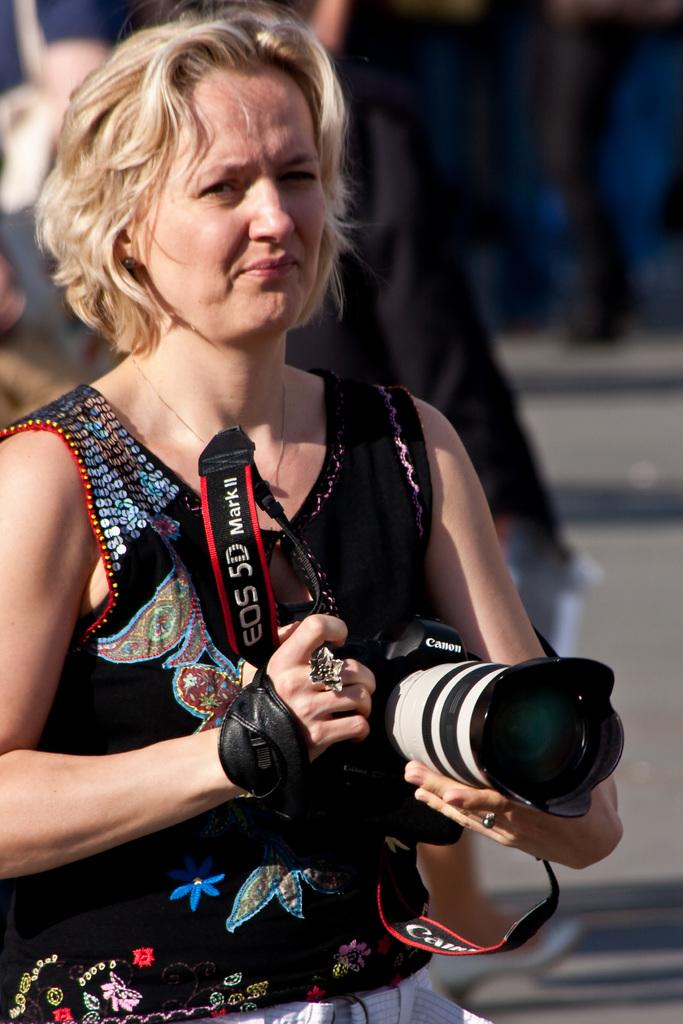Who is the main subject in the image? There is a woman in the image. Where is the woman located in the image? The woman is standing in the middle of the image. What is the woman holding in the image? The woman is holding a camera. What type of cherry is hanging from the tree in the image? There is no tree or cherry present in the image; it features a woman holding a camera. What kind of ornament is on the woman's head in the image? There is no ornament on the woman's head in the image; she is simply holding a camera. 